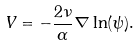<formula> <loc_0><loc_0><loc_500><loc_500>V = - \frac { 2 \nu } { \alpha } \nabla \ln ( \psi ) .</formula> 